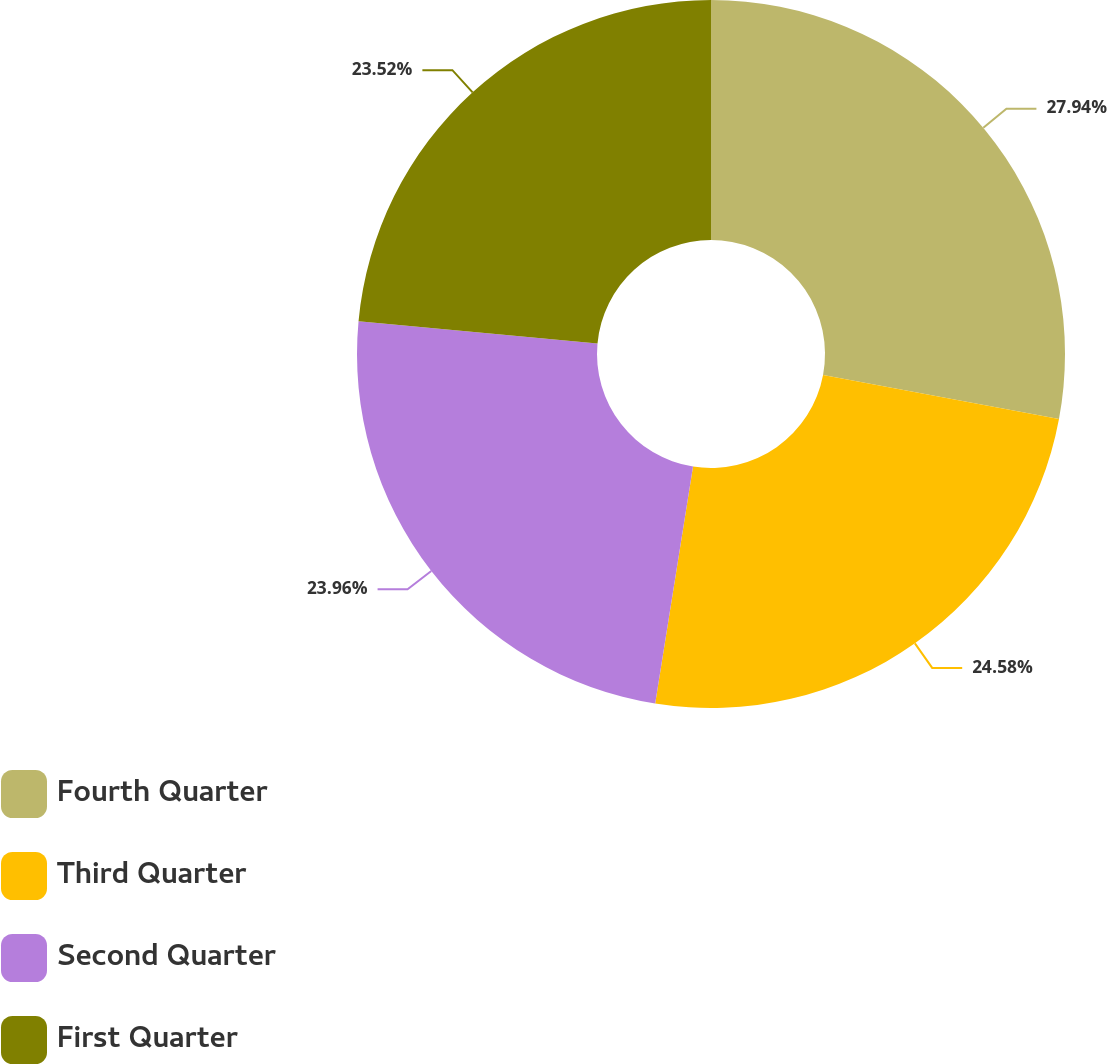Convert chart to OTSL. <chart><loc_0><loc_0><loc_500><loc_500><pie_chart><fcel>Fourth Quarter<fcel>Third Quarter<fcel>Second Quarter<fcel>First Quarter<nl><fcel>27.94%<fcel>24.58%<fcel>23.96%<fcel>23.52%<nl></chart> 